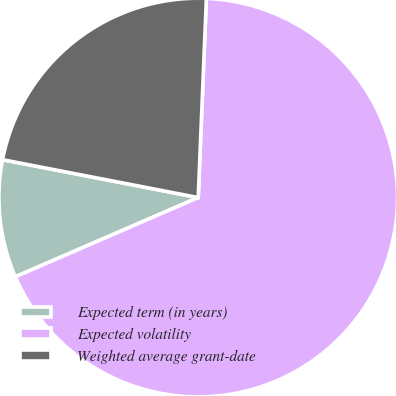Convert chart to OTSL. <chart><loc_0><loc_0><loc_500><loc_500><pie_chart><fcel>Expected term (in years)<fcel>Expected volatility<fcel>Weighted average grant-date<nl><fcel>9.55%<fcel>67.84%<fcel>22.61%<nl></chart> 